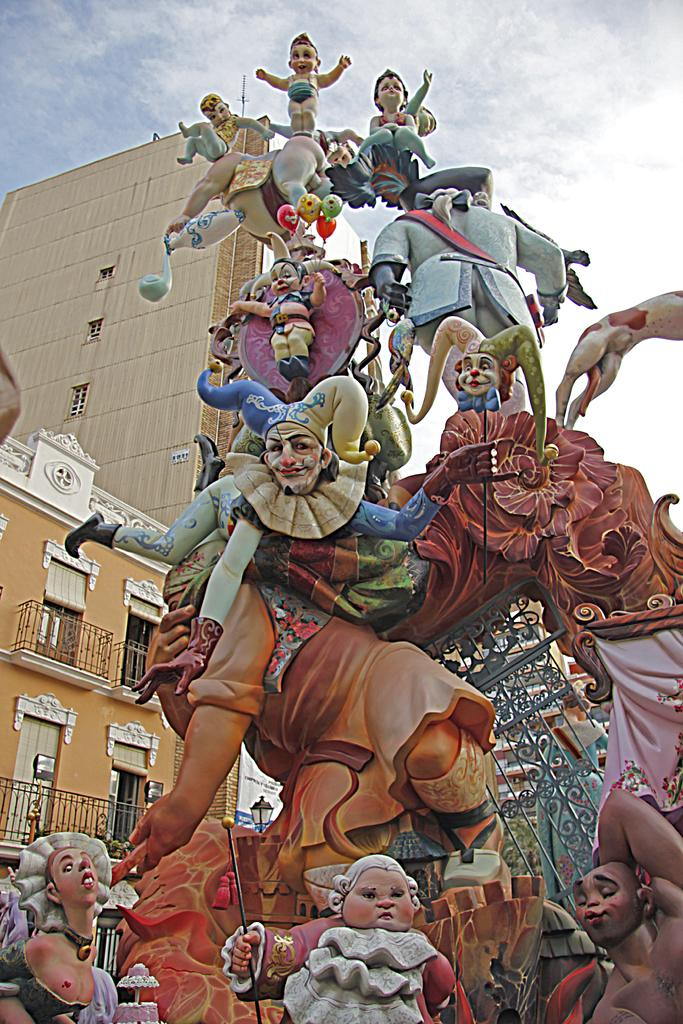What type of artwork can be seen in the image? There are sculptures in the image. What can be seen in the distance behind the sculptures? There are buildings in the background of the image. What part of the natural environment is visible in the image? The sky is visible in the background of the image. What type of rail can be seen connecting the sculptures in the image? There is no rail present in the image; it only features sculptures and buildings in the background. 